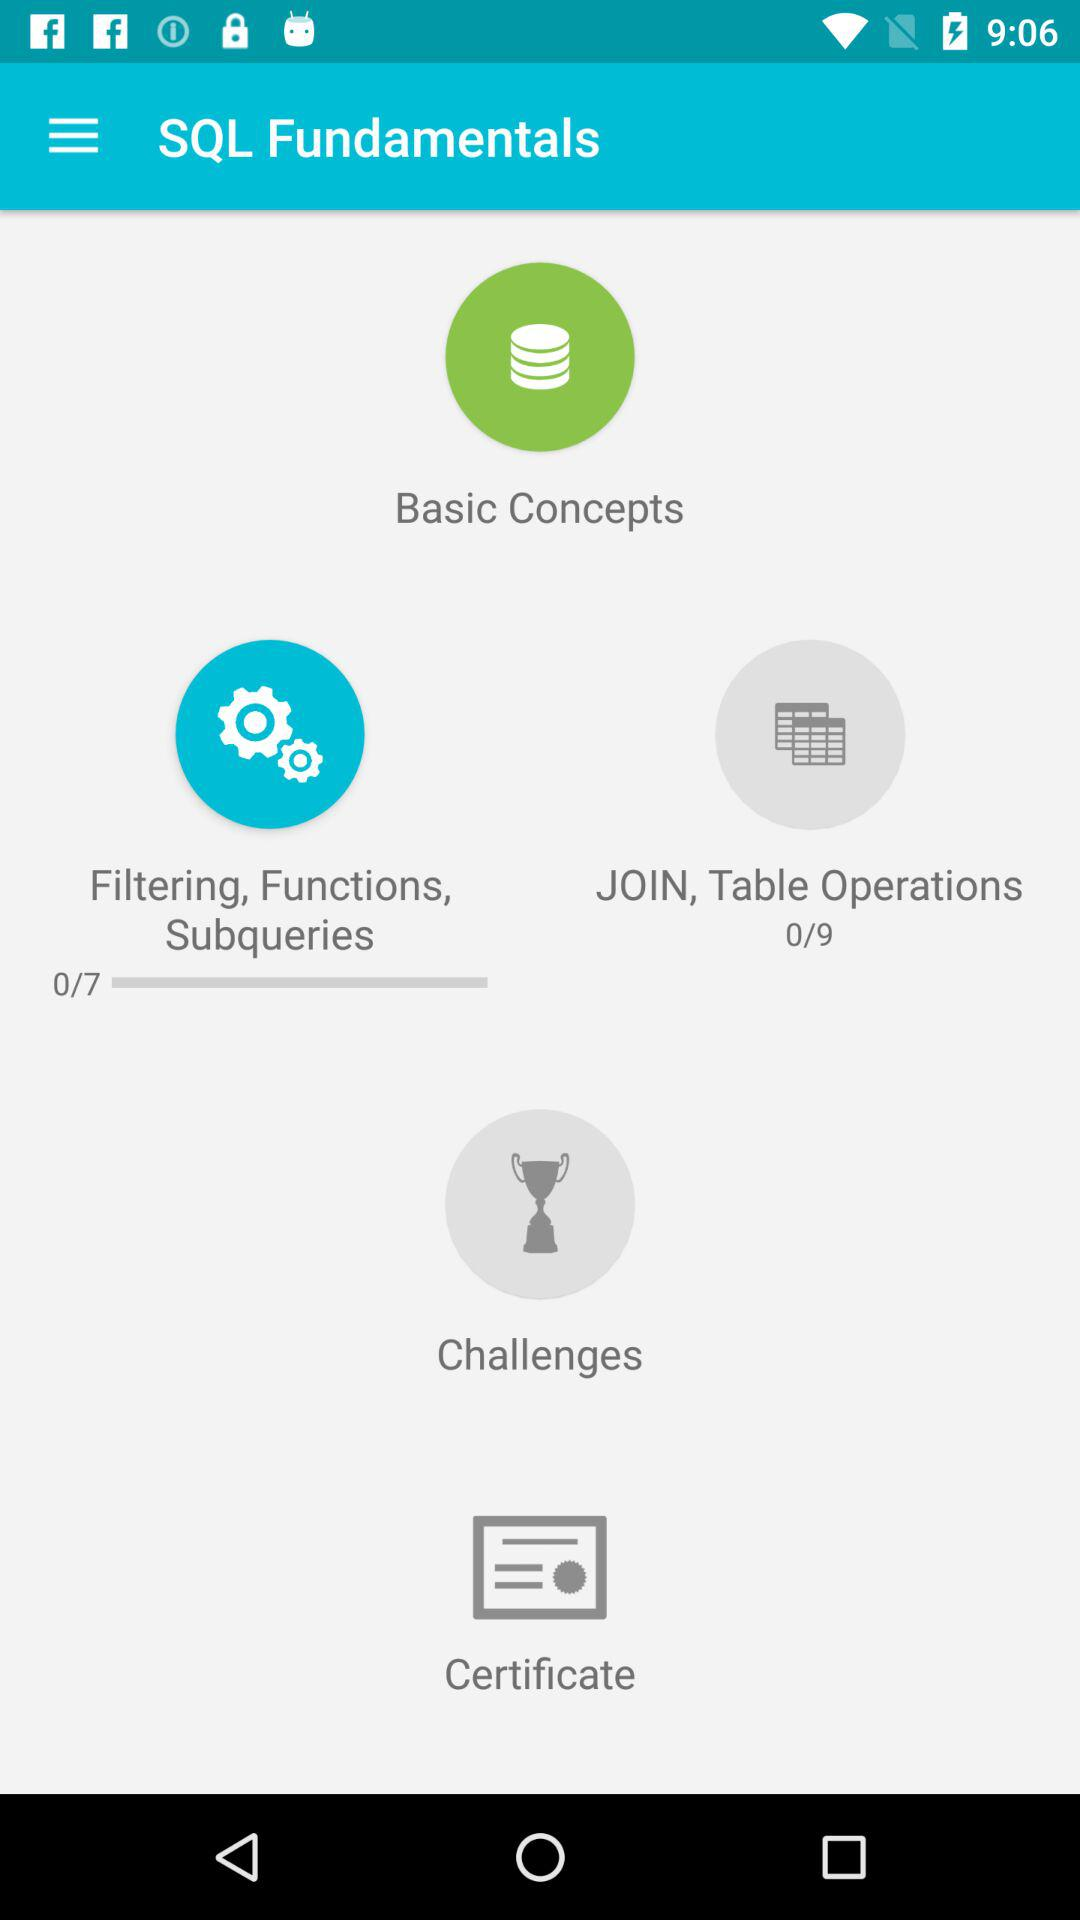What is the application name? The application name is "SQL Fundamentals". 